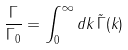<formula> <loc_0><loc_0><loc_500><loc_500>\frac { \Gamma } { \Gamma _ { 0 } } = \int _ { 0 } ^ { \infty } d k _ { \| } \, \tilde { \Gamma } ( k _ { \| } )</formula> 